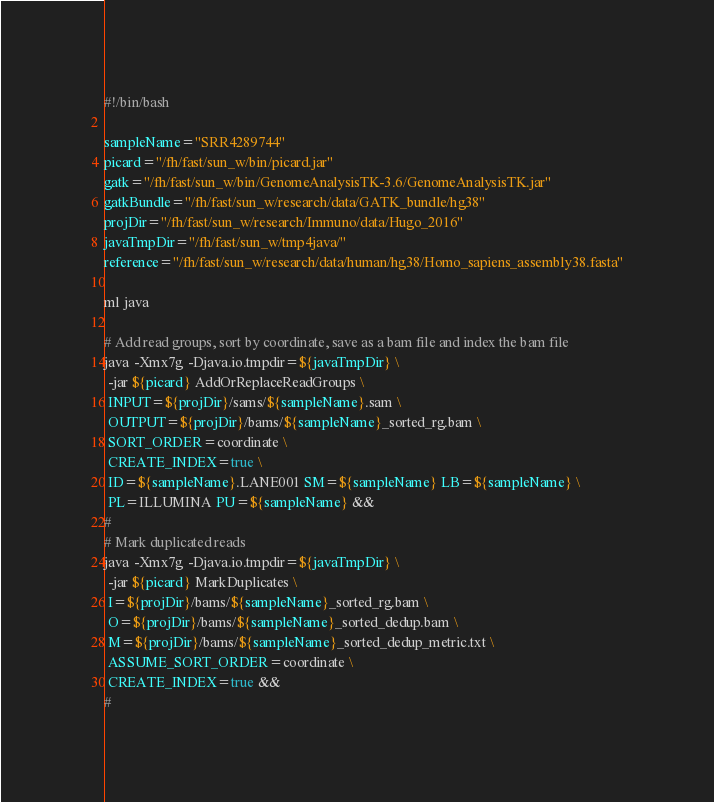Convert code to text. <code><loc_0><loc_0><loc_500><loc_500><_Bash_>#!/bin/bash

sampleName="SRR4289744"
picard="/fh/fast/sun_w/bin/picard.jar"
gatk="/fh/fast/sun_w/bin/GenomeAnalysisTK-3.6/GenomeAnalysisTK.jar"
gatkBundle="/fh/fast/sun_w/research/data/GATK_bundle/hg38"
projDir="/fh/fast/sun_w/research/Immuno/data/Hugo_2016"
javaTmpDir="/fh/fast/sun_w/tmp4java/"
reference="/fh/fast/sun_w/research/data/human/hg38/Homo_sapiens_assembly38.fasta"

ml java

# Add read groups, sort by coordinate, save as a bam file and index the bam file
java -Xmx7g -Djava.io.tmpdir=${javaTmpDir} \
 -jar ${picard} AddOrReplaceReadGroups \
 INPUT=${projDir}/sams/${sampleName}.sam \
 OUTPUT=${projDir}/bams/${sampleName}_sorted_rg.bam \
 SORT_ORDER=coordinate \
 CREATE_INDEX=true \
 ID=${sampleName}.LANE001 SM=${sampleName} LB=${sampleName} \
 PL=ILLUMINA PU=${sampleName} &&
#
# Mark duplicated reads
java -Xmx7g -Djava.io.tmpdir=${javaTmpDir} \
 -jar ${picard} MarkDuplicates \
 I=${projDir}/bams/${sampleName}_sorted_rg.bam \
 O=${projDir}/bams/${sampleName}_sorted_dedup.bam \
 M=${projDir}/bams/${sampleName}_sorted_dedup_metric.txt \
 ASSUME_SORT_ORDER=coordinate \
 CREATE_INDEX=true &&
#</code> 